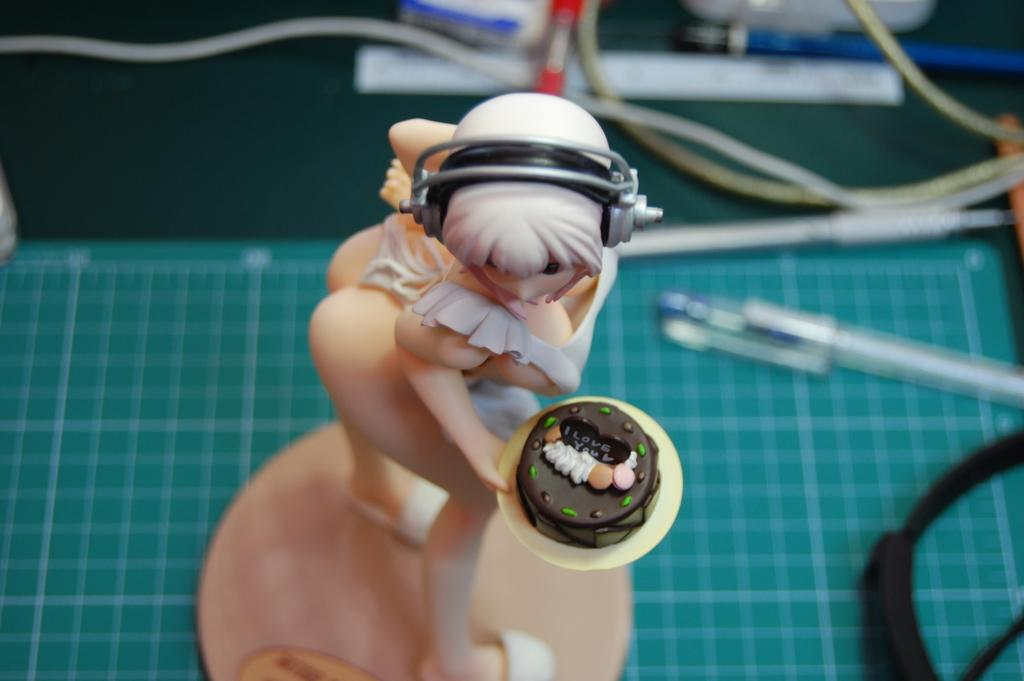What type of toy can be seen in the image? There is a toy in the image, but the specific type is not mentioned. What writing instrument is present in the image? There is a pen in the image. What type of electronic components are visible in the image? There are cables in the image. What surface are the other objects placed on in the image? There are other objects on a platform in the image. Can you see a bat flying in the image? No, there is no bat present in the image. What type of loaf is being used as a prop in the image? There is no loaf present in the image. 